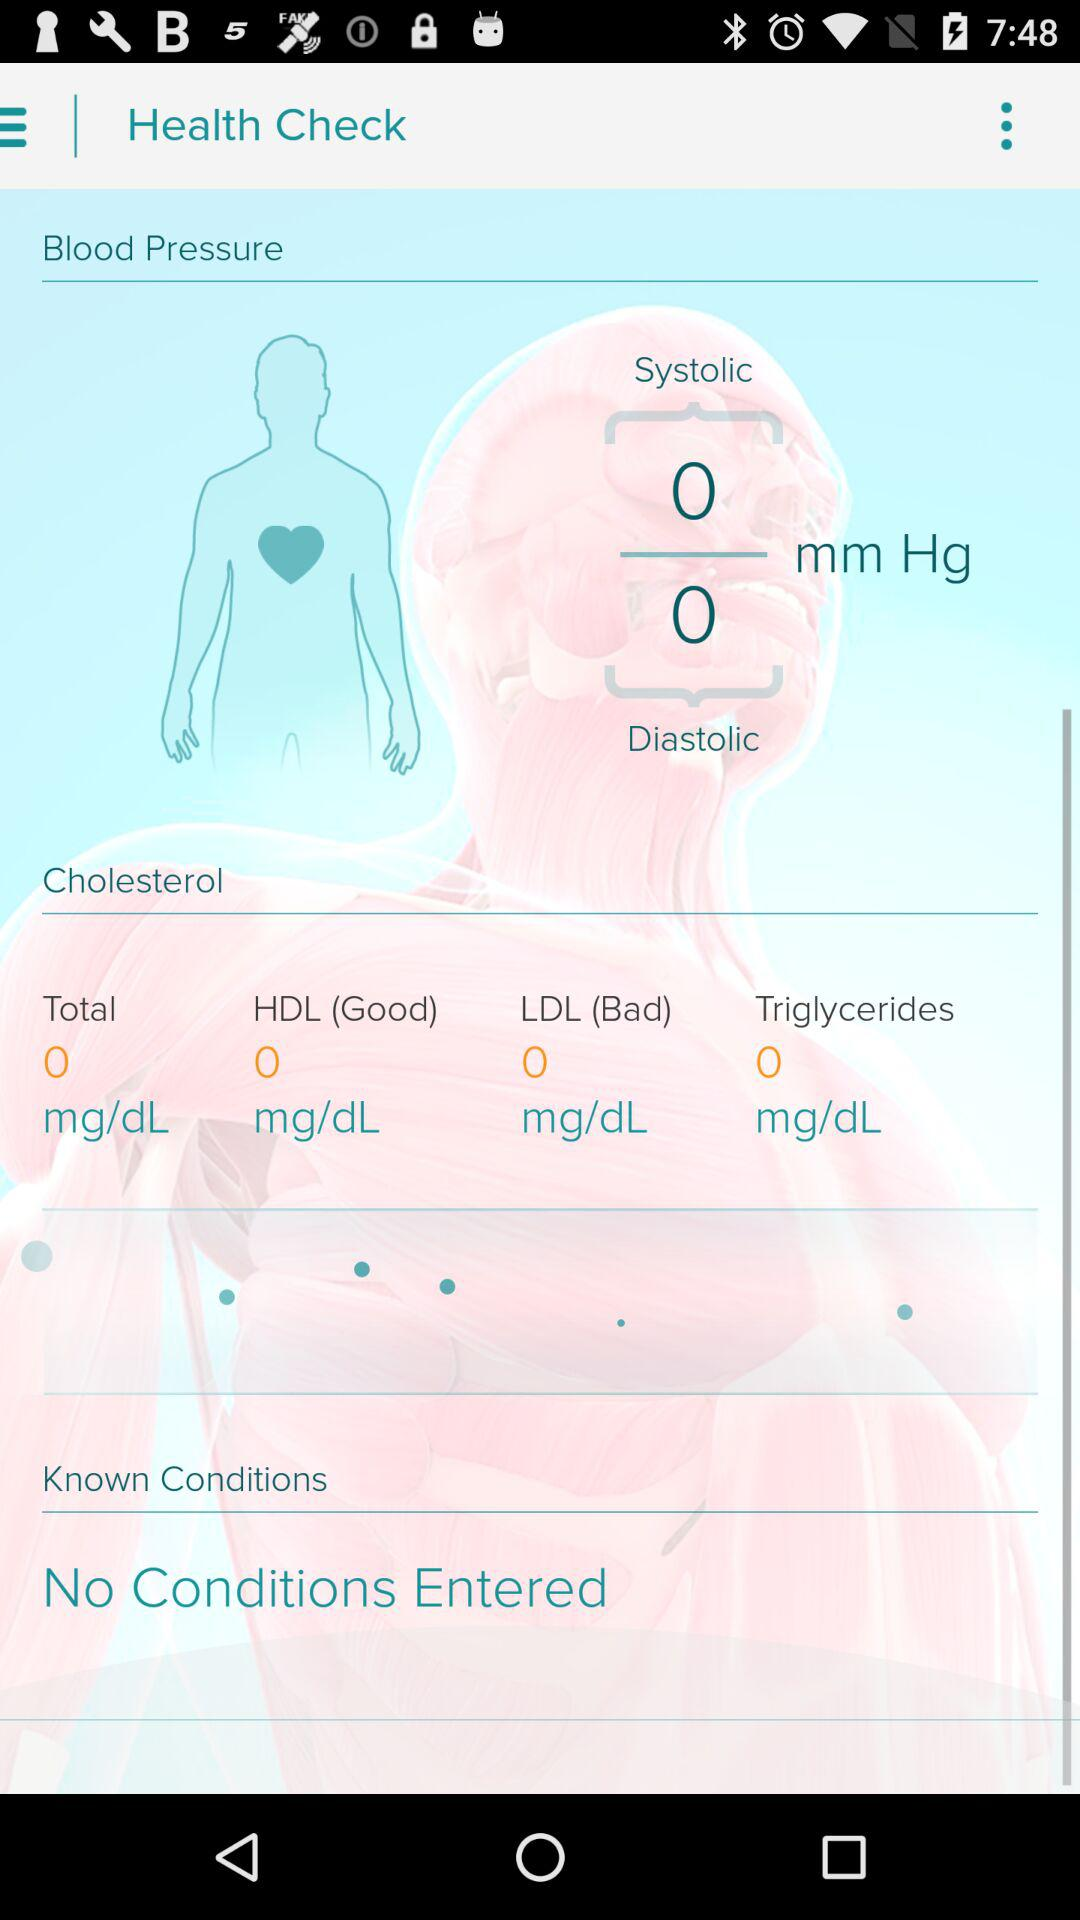What category of cholesterol is "Bad"? The "Bad" category of cholesterol is LDL. 